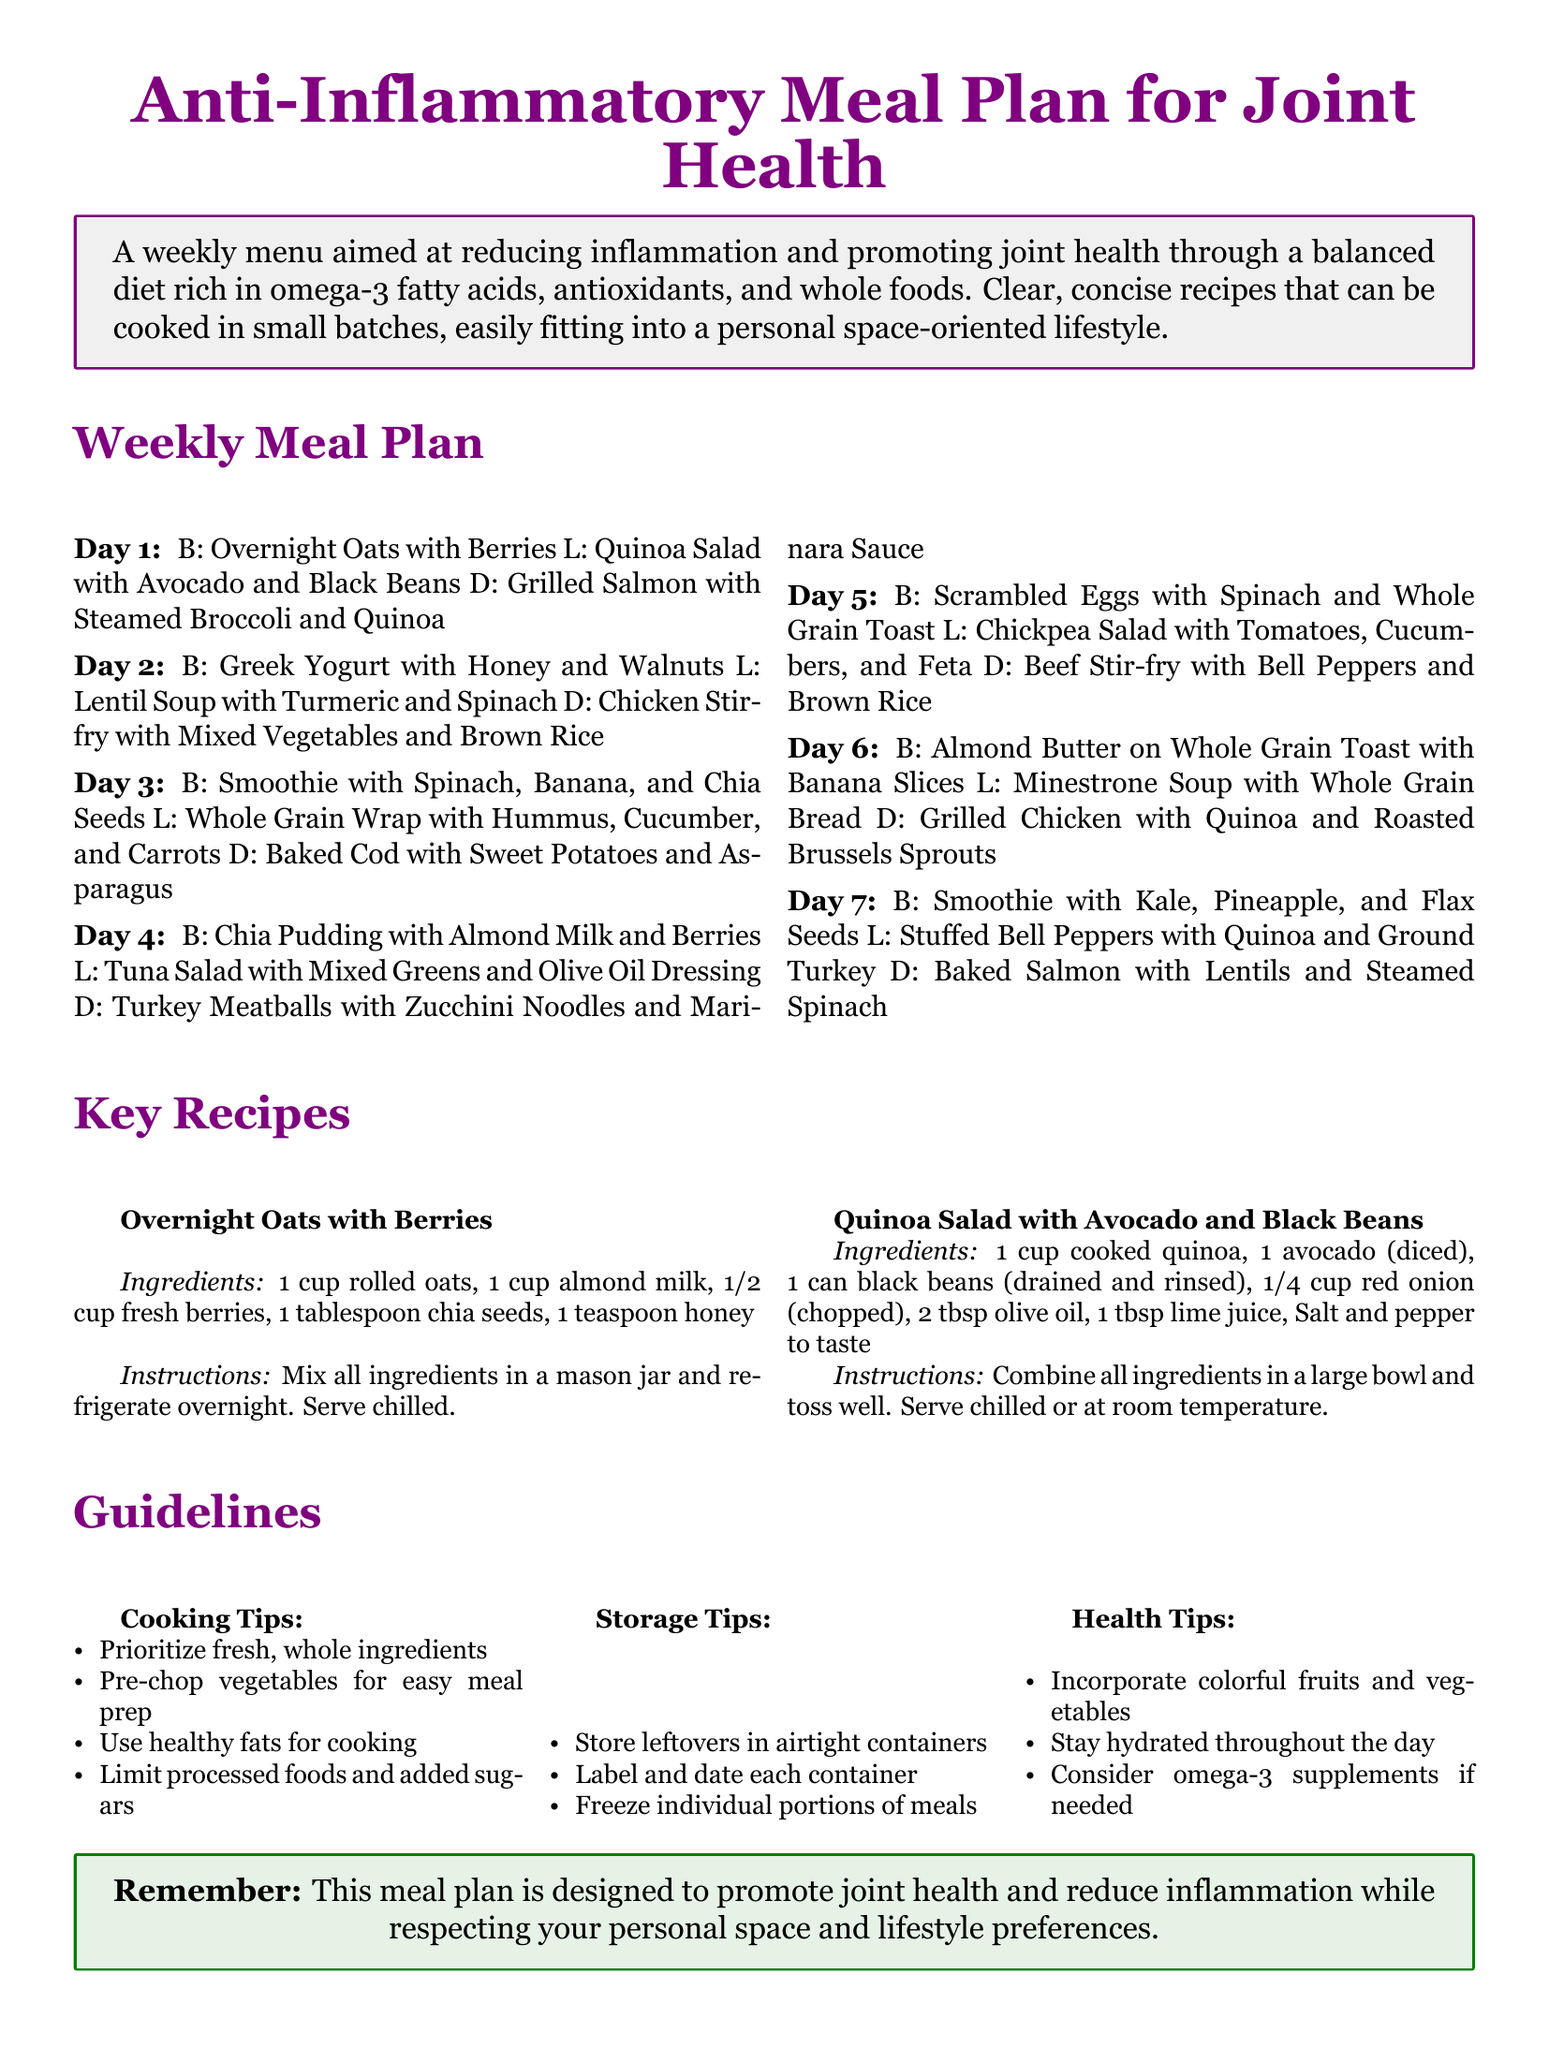What is the title of the meal plan? The title of the meal plan is prominently displayed at the top of the document.
Answer: Anti-Inflammatory Meal Plan for Joint Health How many days does the meal plan cover? The meal plan outlines meals for each day of the week.
Answer: 7 days What is the main purpose of the meal plan? The main purpose is stated in the introduction of the document.
Answer: Reducing inflammation and promoting joint health What is the primary ingredient in the overnight oats recipe? The primary ingredient is listed first in the ingredients section for the recipe.
Answer: Rolled oats On which day is Chicken Stir-fry included? The day for Chicken Stir-fry is clearly stated in the weekly meal plan section of the document.
Answer: Day 2 What type of soup is included on Day 6 for lunch? The type of soup is mentioned in the meal description for that specific day.
Answer: Minestrone Soup What should be done with leftover meals? The document provides a specific guideline regarding the storage of leftover meals.
Answer: Store in airtight containers What is suggested if omega-3 intake is insufficient? This advice is found in the health tips section of the document.
Answer: Consider omega-3 supplements 